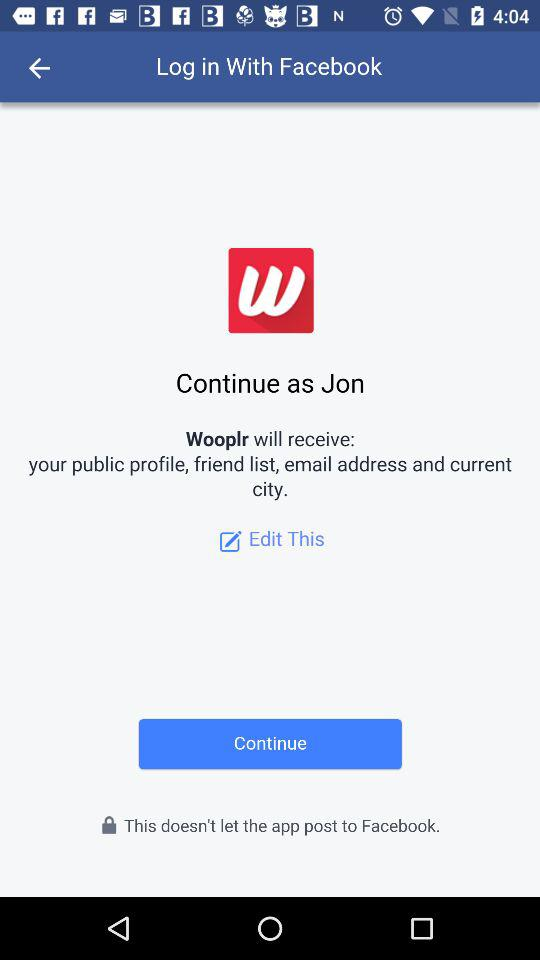What application can be used for logging in? The application that can be used for logging in is "Facebook". 